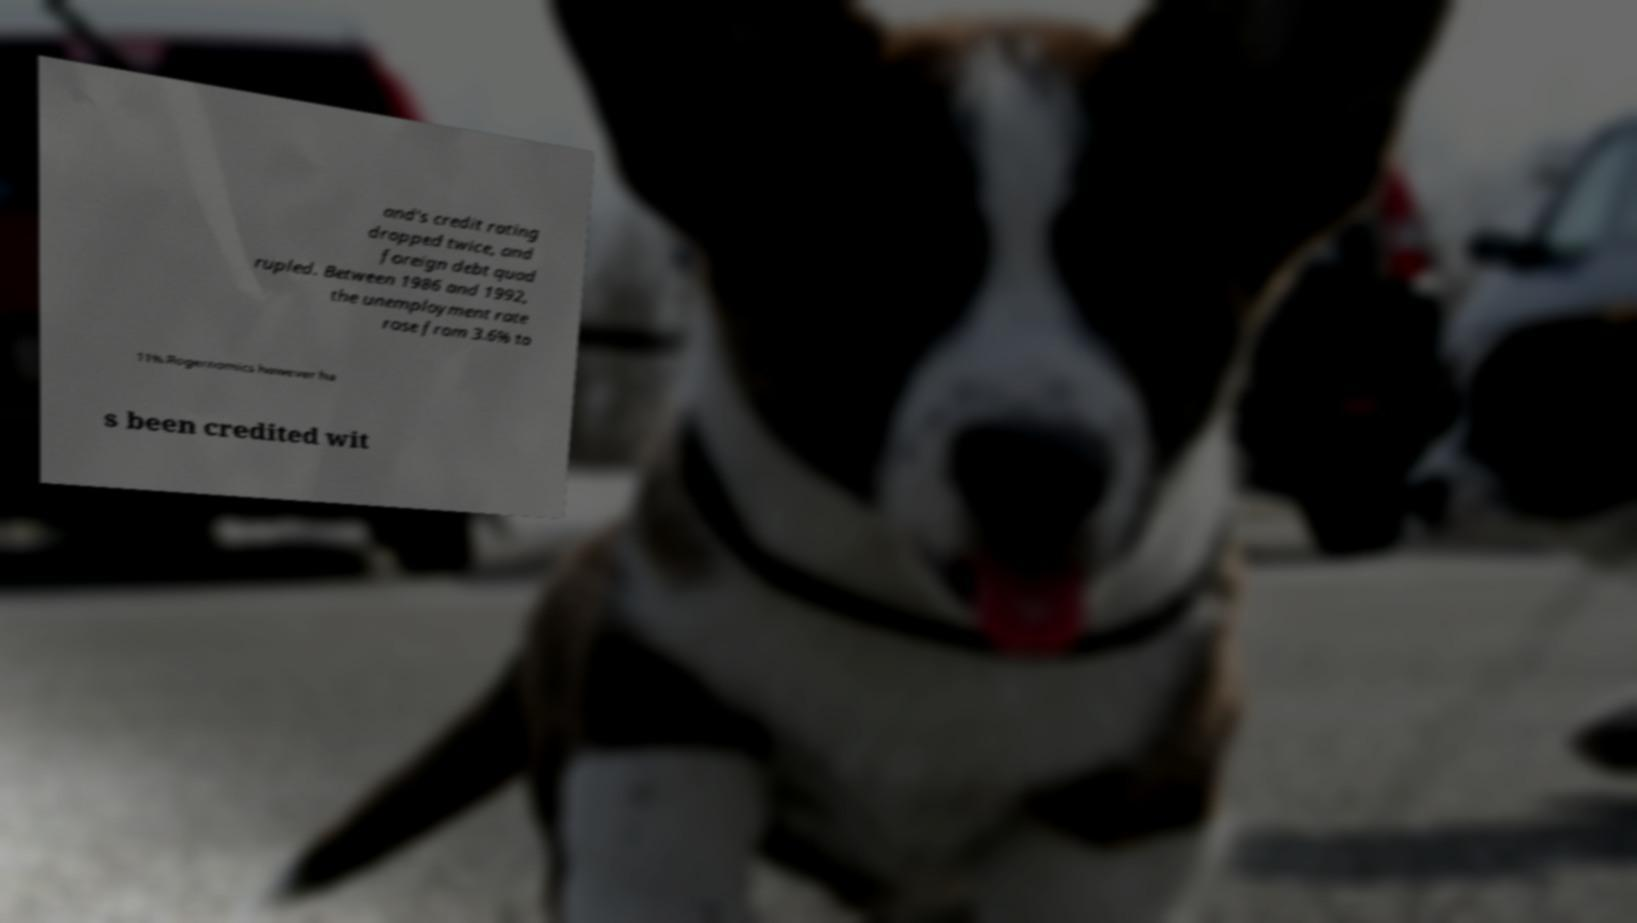There's text embedded in this image that I need extracted. Can you transcribe it verbatim? and's credit rating dropped twice, and foreign debt quad rupled. Between 1986 and 1992, the unemployment rate rose from 3.6% to 11%.Rogernomics however ha s been credited wit 